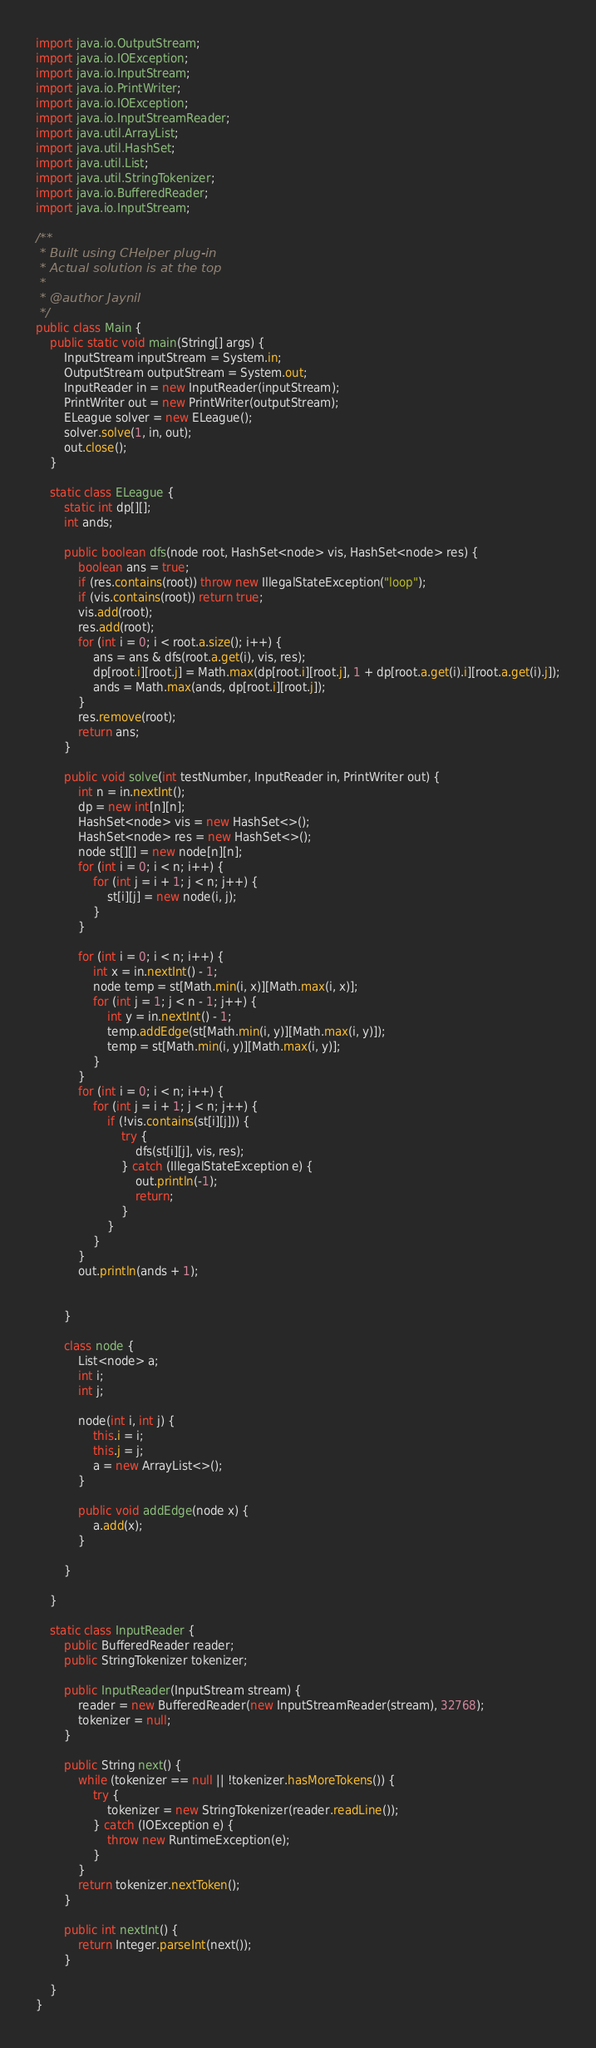Convert code to text. <code><loc_0><loc_0><loc_500><loc_500><_Java_>import java.io.OutputStream;
import java.io.IOException;
import java.io.InputStream;
import java.io.PrintWriter;
import java.io.IOException;
import java.io.InputStreamReader;
import java.util.ArrayList;
import java.util.HashSet;
import java.util.List;
import java.util.StringTokenizer;
import java.io.BufferedReader;
import java.io.InputStream;

/**
 * Built using CHelper plug-in
 * Actual solution is at the top
 *
 * @author Jaynil
 */
public class Main {
    public static void main(String[] args) {
        InputStream inputStream = System.in;
        OutputStream outputStream = System.out;
        InputReader in = new InputReader(inputStream);
        PrintWriter out = new PrintWriter(outputStream);
        ELeague solver = new ELeague();
        solver.solve(1, in, out);
        out.close();
    }

    static class ELeague {
        static int dp[][];
        int ands;

        public boolean dfs(node root, HashSet<node> vis, HashSet<node> res) {
            boolean ans = true;
            if (res.contains(root)) throw new IllegalStateException("loop");
            if (vis.contains(root)) return true;
            vis.add(root);
            res.add(root);
            for (int i = 0; i < root.a.size(); i++) {
                ans = ans & dfs(root.a.get(i), vis, res);
                dp[root.i][root.j] = Math.max(dp[root.i][root.j], 1 + dp[root.a.get(i).i][root.a.get(i).j]);
                ands = Math.max(ands, dp[root.i][root.j]);
            }
            res.remove(root);
            return ans;
        }

        public void solve(int testNumber, InputReader in, PrintWriter out) {
            int n = in.nextInt();
            dp = new int[n][n];
            HashSet<node> vis = new HashSet<>();
            HashSet<node> res = new HashSet<>();
            node st[][] = new node[n][n];
            for (int i = 0; i < n; i++) {
                for (int j = i + 1; j < n; j++) {
                    st[i][j] = new node(i, j);
                }
            }

            for (int i = 0; i < n; i++) {
                int x = in.nextInt() - 1;
                node temp = st[Math.min(i, x)][Math.max(i, x)];
                for (int j = 1; j < n - 1; j++) {
                    int y = in.nextInt() - 1;
                    temp.addEdge(st[Math.min(i, y)][Math.max(i, y)]);
                    temp = st[Math.min(i, y)][Math.max(i, y)];
                }
            }
            for (int i = 0; i < n; i++) {
                for (int j = i + 1; j < n; j++) {
                    if (!vis.contains(st[i][j])) {
                        try {
                            dfs(st[i][j], vis, res);
                        } catch (IllegalStateException e) {
                            out.println(-1);
                            return;
                        }
                    }
                }
            }
            out.println(ands + 1);


        }

        class node {
            List<node> a;
            int i;
            int j;

            node(int i, int j) {
                this.i = i;
                this.j = j;
                a = new ArrayList<>();
            }

            public void addEdge(node x) {
                a.add(x);
            }

        }

    }

    static class InputReader {
        public BufferedReader reader;
        public StringTokenizer tokenizer;

        public InputReader(InputStream stream) {
            reader = new BufferedReader(new InputStreamReader(stream), 32768);
            tokenizer = null;
        }

        public String next() {
            while (tokenizer == null || !tokenizer.hasMoreTokens()) {
                try {
                    tokenizer = new StringTokenizer(reader.readLine());
                } catch (IOException e) {
                    throw new RuntimeException(e);
                }
            }
            return tokenizer.nextToken();
        }

        public int nextInt() {
            return Integer.parseInt(next());
        }

    }
}

</code> 